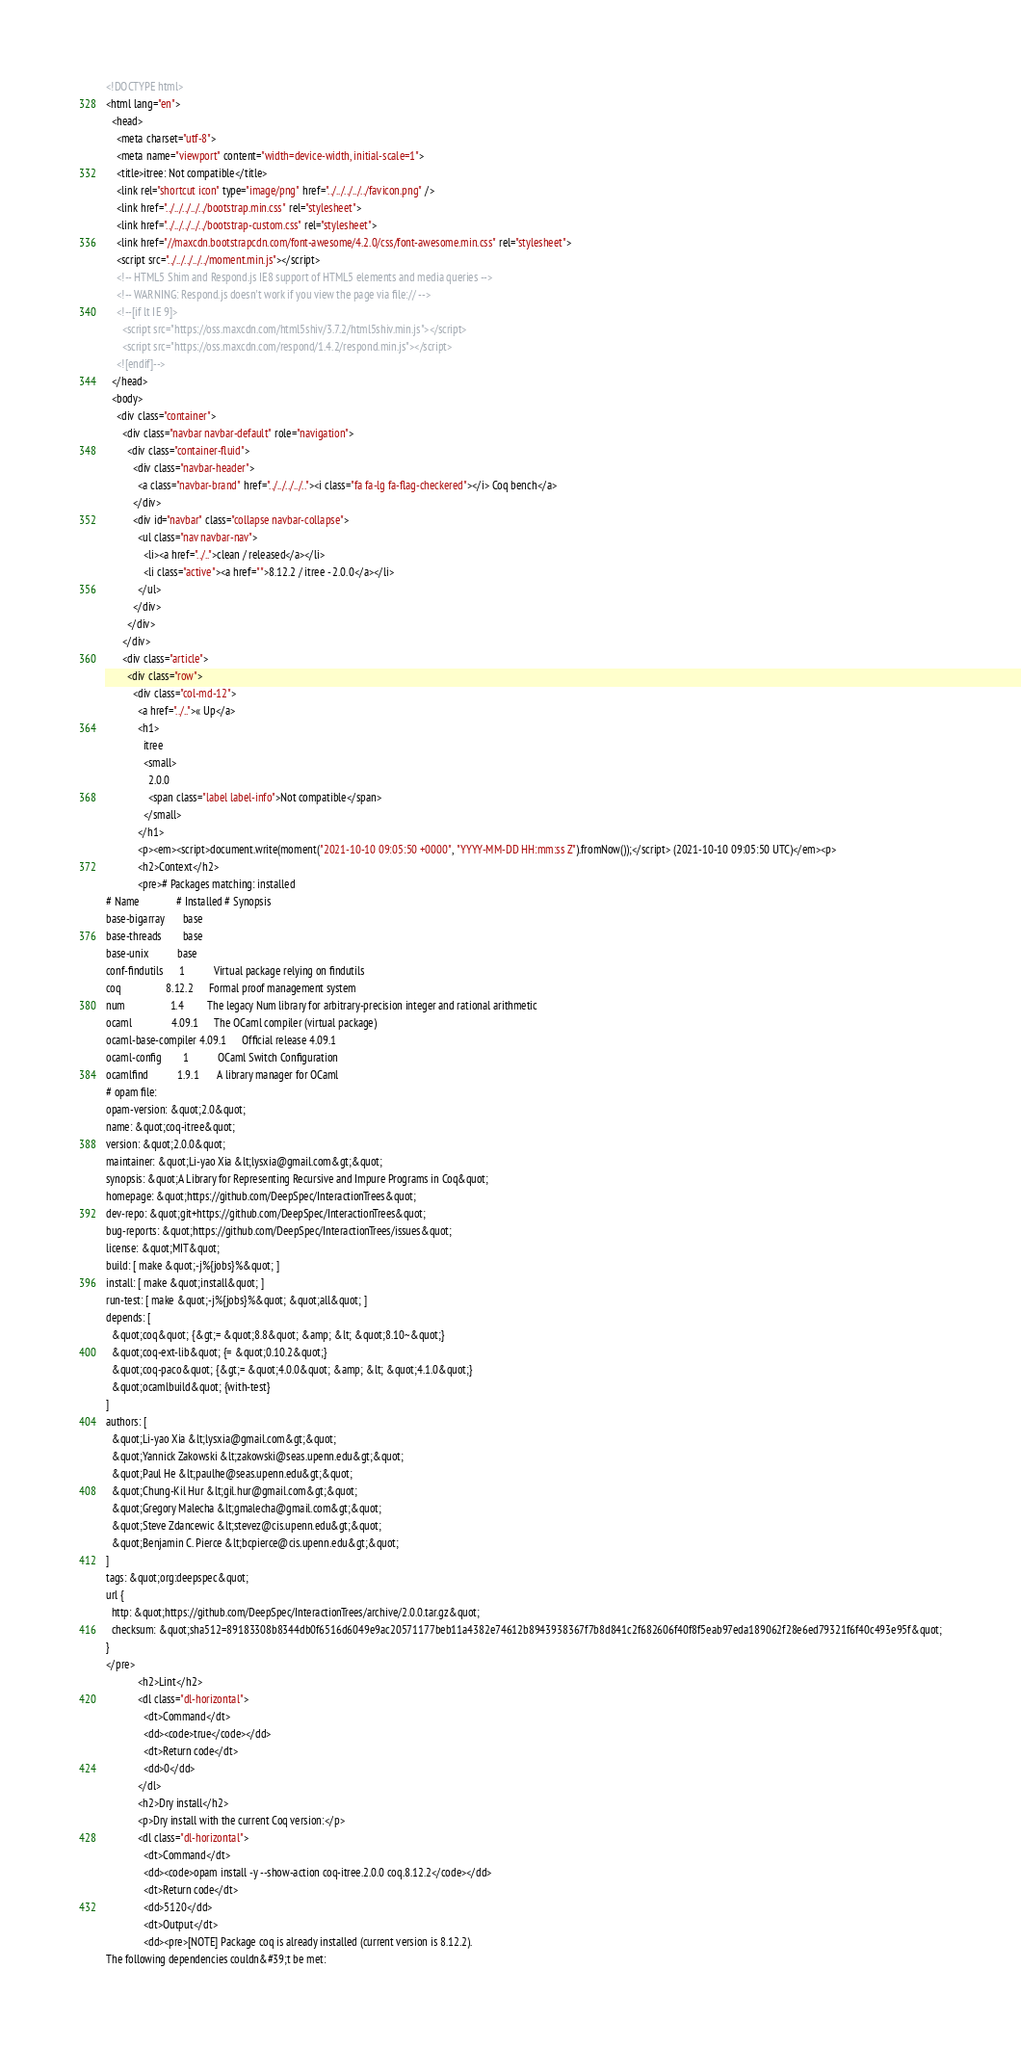<code> <loc_0><loc_0><loc_500><loc_500><_HTML_><!DOCTYPE html>
<html lang="en">
  <head>
    <meta charset="utf-8">
    <meta name="viewport" content="width=device-width, initial-scale=1">
    <title>itree: Not compatible</title>
    <link rel="shortcut icon" type="image/png" href="../../../../../favicon.png" />
    <link href="../../../../../bootstrap.min.css" rel="stylesheet">
    <link href="../../../../../bootstrap-custom.css" rel="stylesheet">
    <link href="//maxcdn.bootstrapcdn.com/font-awesome/4.2.0/css/font-awesome.min.css" rel="stylesheet">
    <script src="../../../../../moment.min.js"></script>
    <!-- HTML5 Shim and Respond.js IE8 support of HTML5 elements and media queries -->
    <!-- WARNING: Respond.js doesn't work if you view the page via file:// -->
    <!--[if lt IE 9]>
      <script src="https://oss.maxcdn.com/html5shiv/3.7.2/html5shiv.min.js"></script>
      <script src="https://oss.maxcdn.com/respond/1.4.2/respond.min.js"></script>
    <![endif]-->
  </head>
  <body>
    <div class="container">
      <div class="navbar navbar-default" role="navigation">
        <div class="container-fluid">
          <div class="navbar-header">
            <a class="navbar-brand" href="../../../../.."><i class="fa fa-lg fa-flag-checkered"></i> Coq bench</a>
          </div>
          <div id="navbar" class="collapse navbar-collapse">
            <ul class="nav navbar-nav">
              <li><a href="../..">clean / released</a></li>
              <li class="active"><a href="">8.12.2 / itree - 2.0.0</a></li>
            </ul>
          </div>
        </div>
      </div>
      <div class="article">
        <div class="row">
          <div class="col-md-12">
            <a href="../..">« Up</a>
            <h1>
              itree
              <small>
                2.0.0
                <span class="label label-info">Not compatible</span>
              </small>
            </h1>
            <p><em><script>document.write(moment("2021-10-10 09:05:50 +0000", "YYYY-MM-DD HH:mm:ss Z").fromNow());</script> (2021-10-10 09:05:50 UTC)</em><p>
            <h2>Context</h2>
            <pre># Packages matching: installed
# Name              # Installed # Synopsis
base-bigarray       base
base-threads        base
base-unix           base
conf-findutils      1           Virtual package relying on findutils
coq                 8.12.2      Formal proof management system
num                 1.4         The legacy Num library for arbitrary-precision integer and rational arithmetic
ocaml               4.09.1      The OCaml compiler (virtual package)
ocaml-base-compiler 4.09.1      Official release 4.09.1
ocaml-config        1           OCaml Switch Configuration
ocamlfind           1.9.1       A library manager for OCaml
# opam file:
opam-version: &quot;2.0&quot;
name: &quot;coq-itree&quot;
version: &quot;2.0.0&quot;
maintainer: &quot;Li-yao Xia &lt;lysxia@gmail.com&gt;&quot;
synopsis: &quot;A Library for Representing Recursive and Impure Programs in Coq&quot;
homepage: &quot;https://github.com/DeepSpec/InteractionTrees&quot;
dev-repo: &quot;git+https://github.com/DeepSpec/InteractionTrees&quot;
bug-reports: &quot;https://github.com/DeepSpec/InteractionTrees/issues&quot;
license: &quot;MIT&quot;
build: [ make &quot;-j%{jobs}%&quot; ]
install: [ make &quot;install&quot; ]
run-test: [ make &quot;-j%{jobs}%&quot; &quot;all&quot; ]
depends: [
  &quot;coq&quot; {&gt;= &quot;8.8&quot; &amp; &lt; &quot;8.10~&quot;}
  &quot;coq-ext-lib&quot; {= &quot;0.10.2&quot;}
  &quot;coq-paco&quot; {&gt;= &quot;4.0.0&quot; &amp; &lt; &quot;4.1.0&quot;}
  &quot;ocamlbuild&quot; {with-test}
]
authors: [
  &quot;Li-yao Xia &lt;lysxia@gmail.com&gt;&quot;
  &quot;Yannick Zakowski &lt;zakowski@seas.upenn.edu&gt;&quot;
  &quot;Paul He &lt;paulhe@seas.upenn.edu&gt;&quot;
  &quot;Chung-Kil Hur &lt;gil.hur@gmail.com&gt;&quot;
  &quot;Gregory Malecha &lt;gmalecha@gmail.com&gt;&quot;
  &quot;Steve Zdancewic &lt;stevez@cis.upenn.edu&gt;&quot;
  &quot;Benjamin C. Pierce &lt;bcpierce@cis.upenn.edu&gt;&quot;
]
tags: &quot;org:deepspec&quot;
url {
  http: &quot;https://github.com/DeepSpec/InteractionTrees/archive/2.0.0.tar.gz&quot;
  checksum: &quot;sha512=89183308b8344db0f6516d6049e9ac20571177beb11a4382e74612b8943938367f7b8d841c2f682606f40f8f5eab97eda189062f28e6ed79321f6f40c493e95f&quot;
}
</pre>
            <h2>Lint</h2>
            <dl class="dl-horizontal">
              <dt>Command</dt>
              <dd><code>true</code></dd>
              <dt>Return code</dt>
              <dd>0</dd>
            </dl>
            <h2>Dry install</h2>
            <p>Dry install with the current Coq version:</p>
            <dl class="dl-horizontal">
              <dt>Command</dt>
              <dd><code>opam install -y --show-action coq-itree.2.0.0 coq.8.12.2</code></dd>
              <dt>Return code</dt>
              <dd>5120</dd>
              <dt>Output</dt>
              <dd><pre>[NOTE] Package coq is already installed (current version is 8.12.2).
The following dependencies couldn&#39;t be met:</code> 